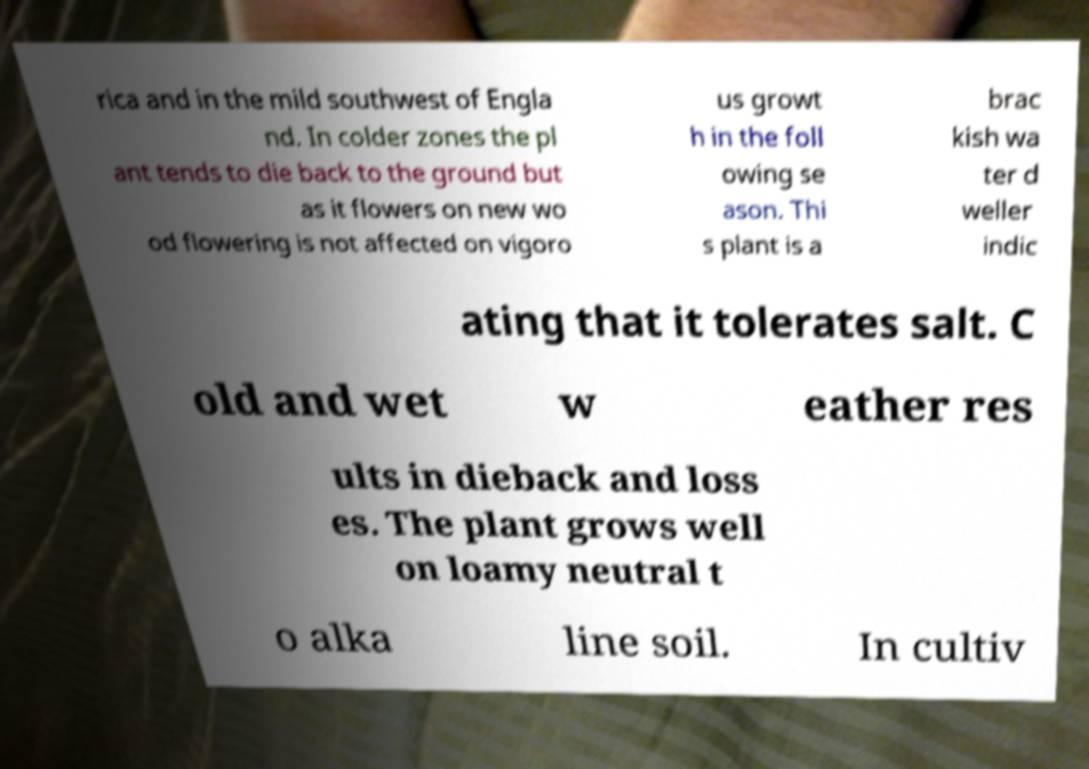Can you read and provide the text displayed in the image?This photo seems to have some interesting text. Can you extract and type it out for me? rica and in the mild southwest of Engla nd. In colder zones the pl ant tends to die back to the ground but as it flowers on new wo od flowering is not affected on vigoro us growt h in the foll owing se ason. Thi s plant is a brac kish wa ter d weller indic ating that it tolerates salt. C old and wet w eather res ults in dieback and loss es. The plant grows well on loamy neutral t o alka line soil. In cultiv 